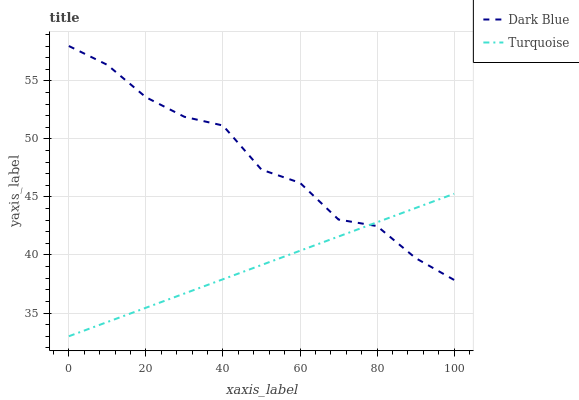Does Turquoise have the minimum area under the curve?
Answer yes or no. Yes. Does Dark Blue have the maximum area under the curve?
Answer yes or no. Yes. Does Turquoise have the maximum area under the curve?
Answer yes or no. No. Is Turquoise the smoothest?
Answer yes or no. Yes. Is Dark Blue the roughest?
Answer yes or no. Yes. Is Turquoise the roughest?
Answer yes or no. No. Does Turquoise have the lowest value?
Answer yes or no. Yes. Does Dark Blue have the highest value?
Answer yes or no. Yes. Does Turquoise have the highest value?
Answer yes or no. No. Does Dark Blue intersect Turquoise?
Answer yes or no. Yes. Is Dark Blue less than Turquoise?
Answer yes or no. No. Is Dark Blue greater than Turquoise?
Answer yes or no. No. 